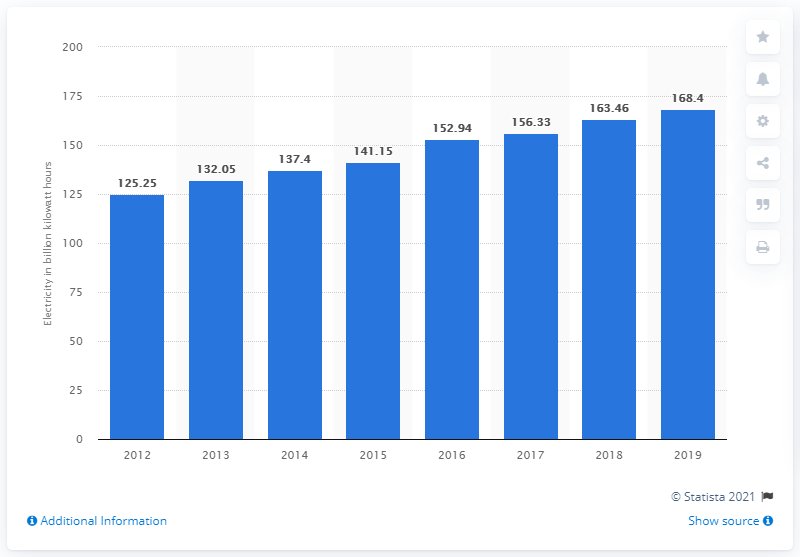Point out several critical features in this image. In 2019, Malaysia generated 168.4 terawatt-hours of electricity. 